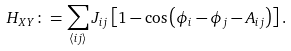<formula> <loc_0><loc_0><loc_500><loc_500>H _ { X Y } \colon = \sum _ { \langle i j \rangle } J _ { i j } \left [ 1 - \cos \left ( \phi _ { i } - \phi _ { j } - A _ { i j } \right ) \right ] .</formula> 